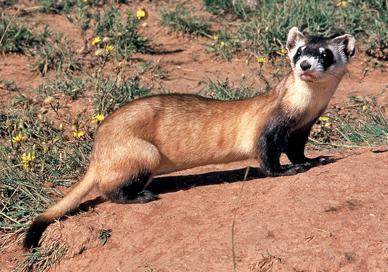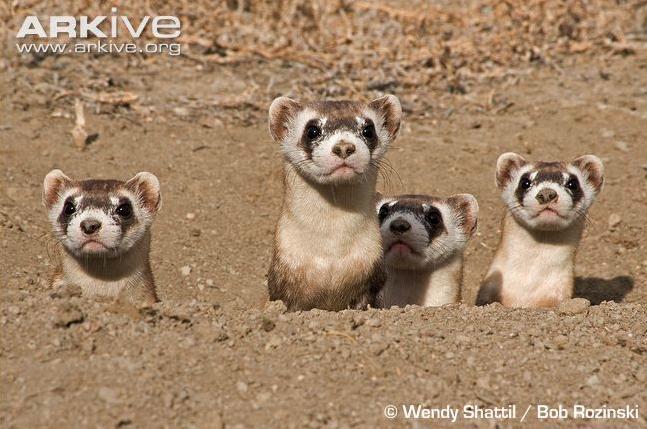The first image is the image on the left, the second image is the image on the right. Examine the images to the left and right. Is the description "The combined images contain five ferrets, and at least three are peering up from a low spot." accurate? Answer yes or no. Yes. 